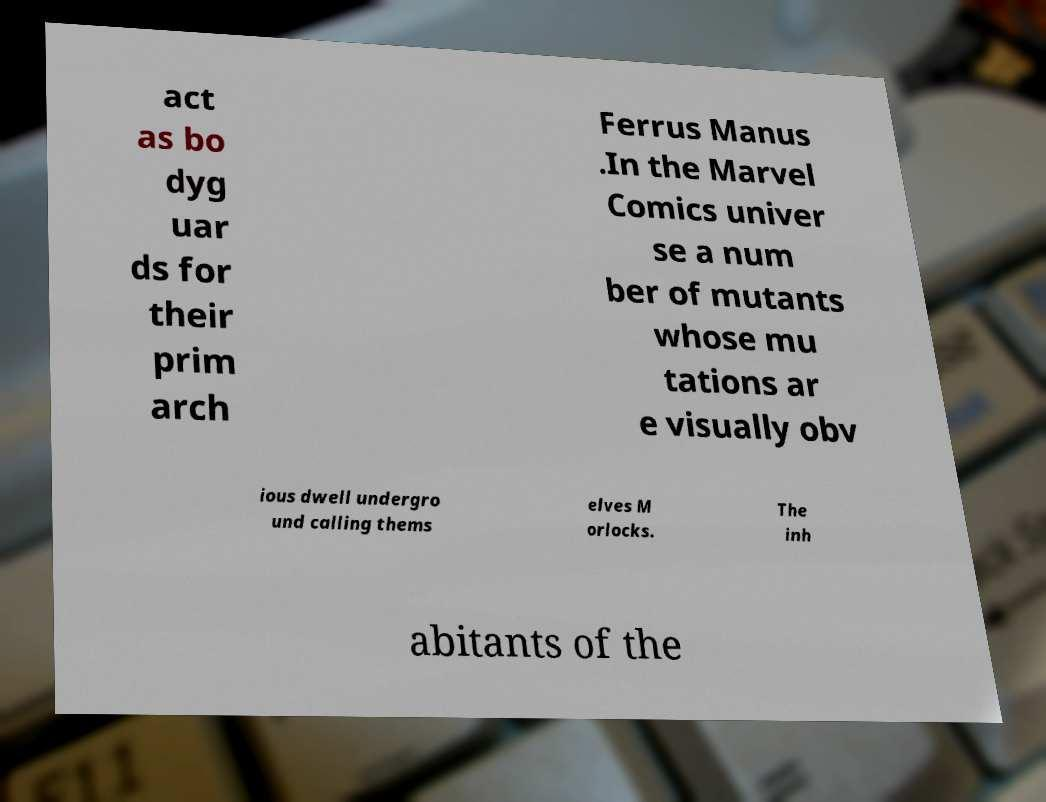For documentation purposes, I need the text within this image transcribed. Could you provide that? act as bo dyg uar ds for their prim arch Ferrus Manus .In the Marvel Comics univer se a num ber of mutants whose mu tations ar e visually obv ious dwell undergro und calling thems elves M orlocks. The inh abitants of the 